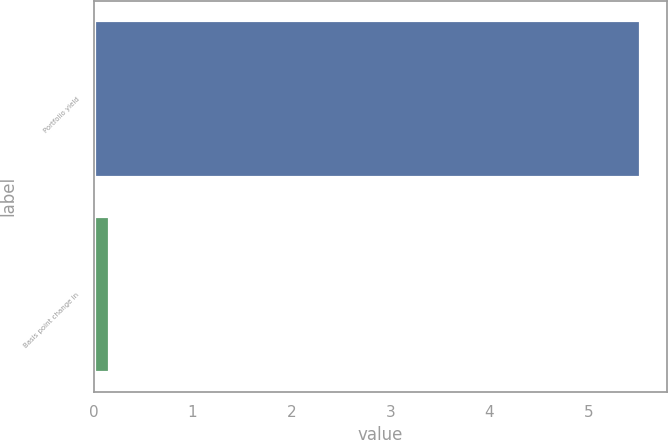<chart> <loc_0><loc_0><loc_500><loc_500><bar_chart><fcel>Portfolio yield<fcel>Basis point change in<nl><fcel>5.52<fcel>0.16<nl></chart> 